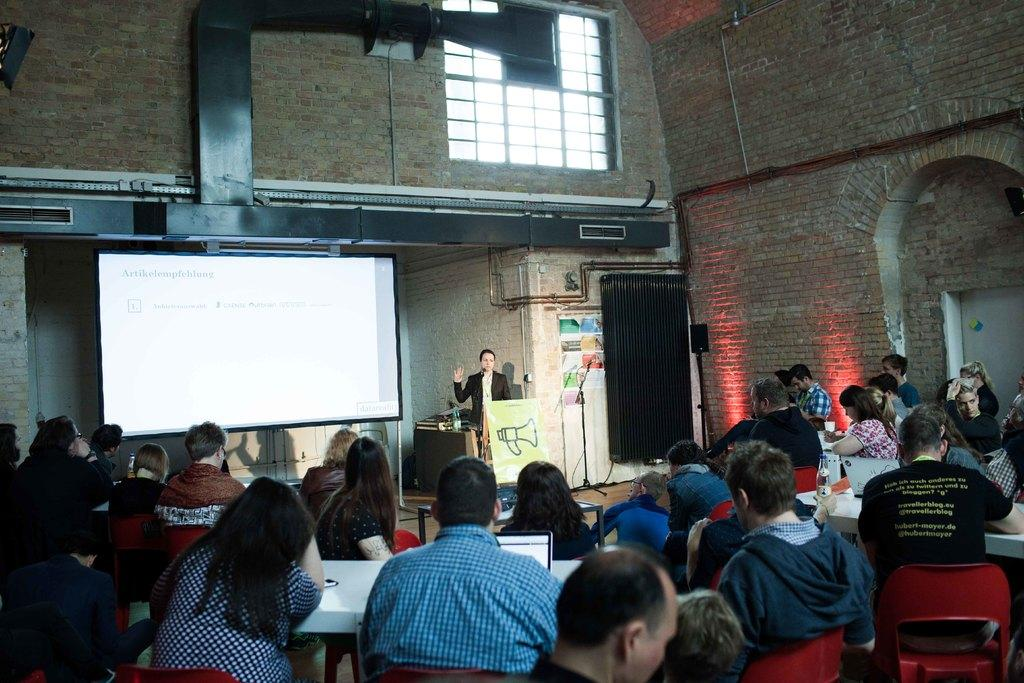What are the people in the image doing? The people in the image are sitting on chairs. Is there anyone standing in the image? Yes, there is a person standing in front of the seated people. What is being displayed in front of the seated people? There is a projector display in front of the seated people. What can be seen on the right side of the image? There is a wall of bricks on the right side of the image. What type of guitar is the crow playing in the image? There is no guitar or crow present in the image. In which direction is the north located in the image? The concept of north is not relevant to the image, as it does not contain any geographical or directional information. 